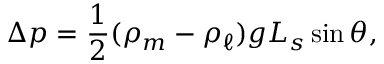<formula> <loc_0><loc_0><loc_500><loc_500>\Delta p = \frac { 1 } { 2 } ( \rho _ { m } - \rho _ { \ell } ) g L _ { s } \sin \theta ,</formula> 